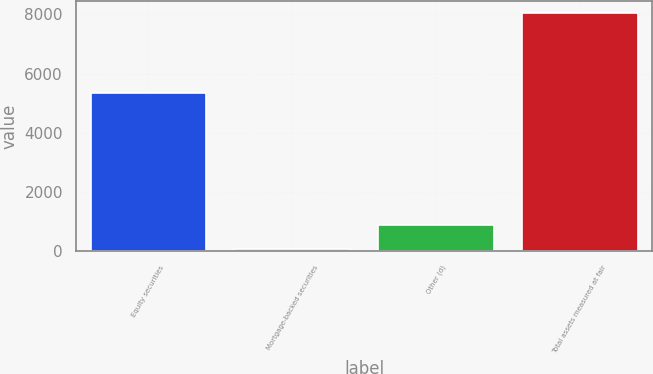Convert chart. <chart><loc_0><loc_0><loc_500><loc_500><bar_chart><fcel>Equity securities<fcel>Mortgage-backed securities<fcel>Other (d)<fcel>Total assets measured at fair<nl><fcel>5342<fcel>82<fcel>885<fcel>8044<nl></chart> 